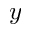<formula> <loc_0><loc_0><loc_500><loc_500>y</formula> 